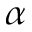Convert formula to latex. <formula><loc_0><loc_0><loc_500><loc_500>\alpha</formula> 